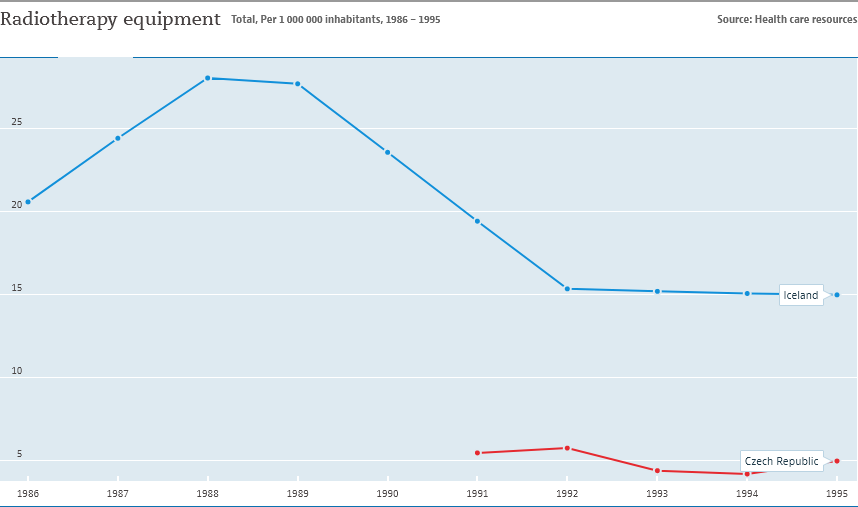What trends do we see in the availability of radiotherapy equipment in Iceland from 1986 to 1995? The graph shows a declining trend in the availability of radiotherapy equipment in Iceland from 1986 to 1995. It peaks around 1989 with over 25 units per million inhabitants and then steadily decreases to about 7 units per million by 1995. 